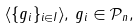<formula> <loc_0><loc_0><loc_500><loc_500>\langle \{ g _ { i } \} _ { i \in I } \rangle , \, g _ { i } \in \mathcal { P } _ { n } ,</formula> 